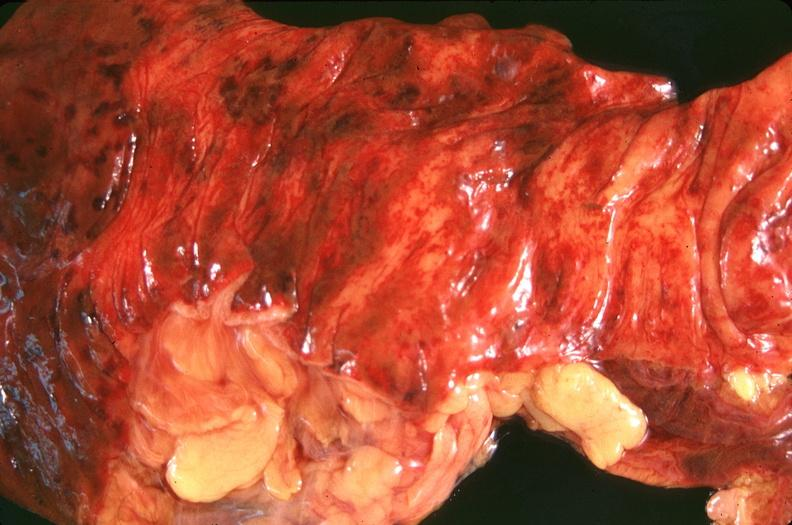does parathyroid show small intestine, ischemic bowel?
Answer the question using a single word or phrase. No 